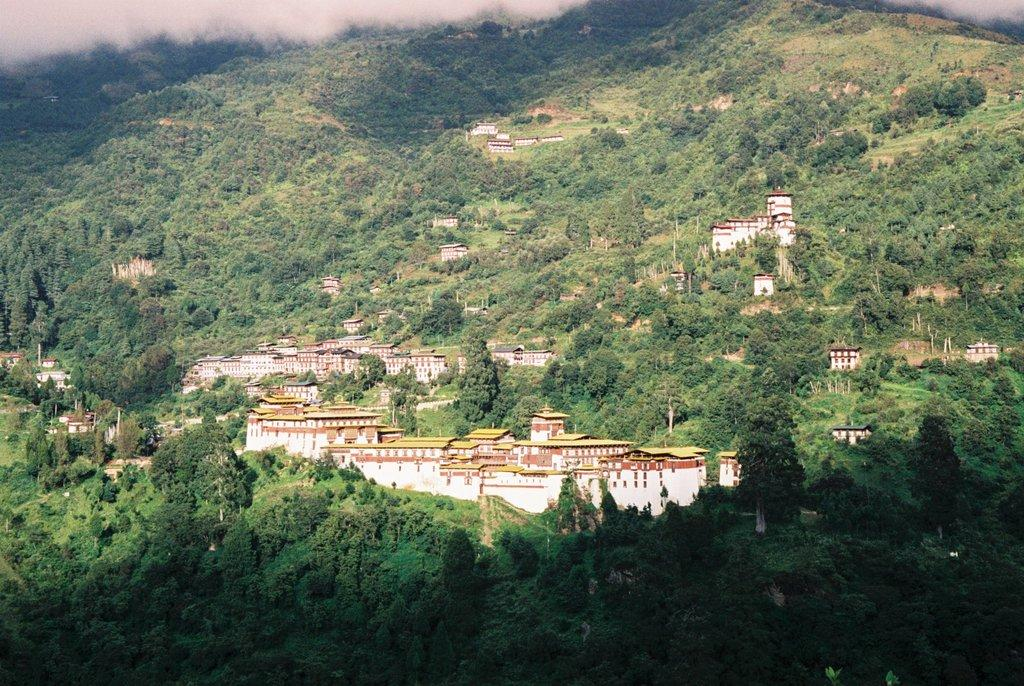What type of structures can be seen in the image? There are buildings on a hill in the image. What other natural elements are visible in the image? There are trees visible in the image. What atmospheric condition is present in the image? There is fog present in the image. Where is the pencil located in the image? There is no pencil present in the image. What type of mailbox can be seen near the trees in the image? There is no mailbox present in the image. 